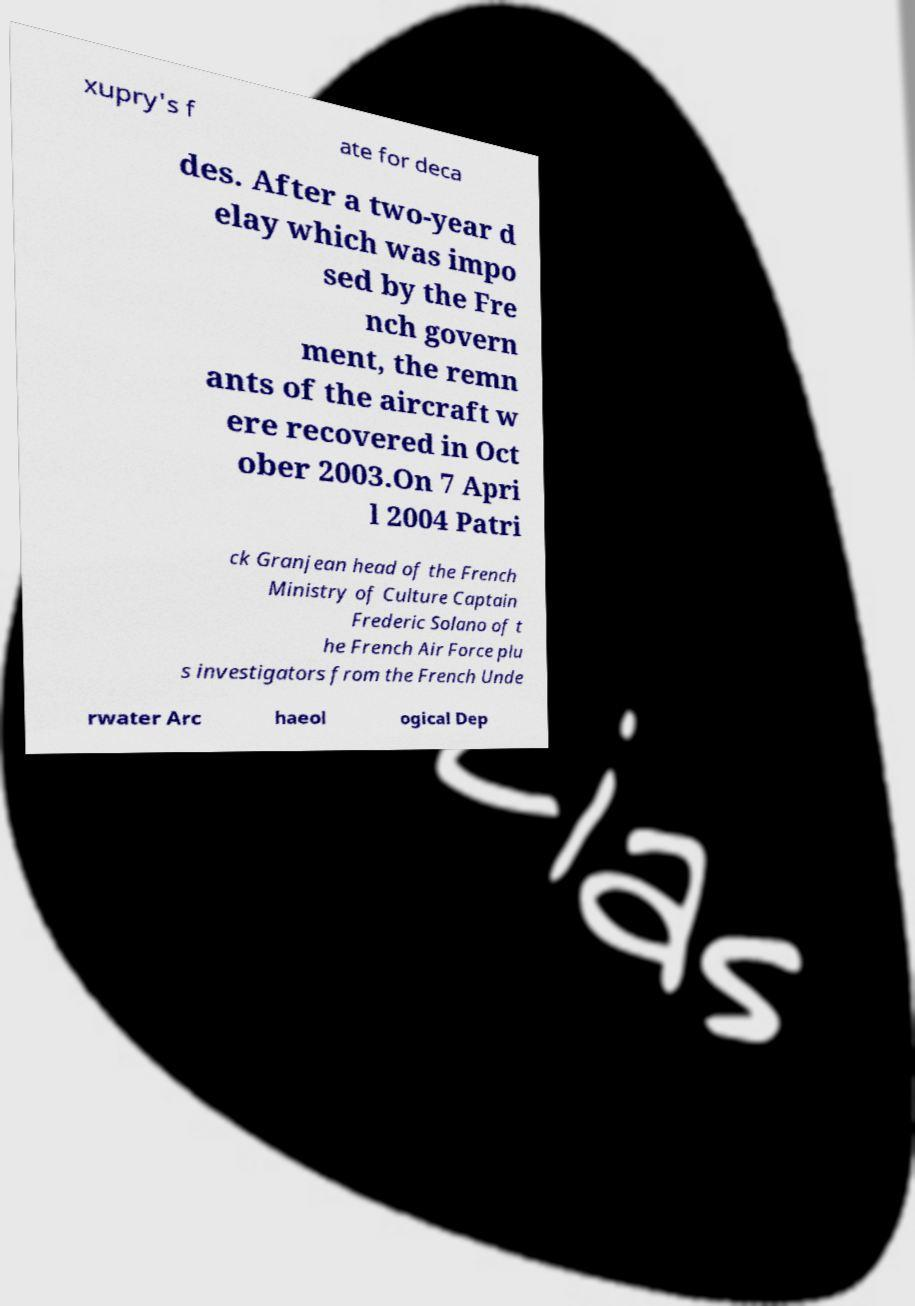For documentation purposes, I need the text within this image transcribed. Could you provide that? xupry's f ate for deca des. After a two-year d elay which was impo sed by the Fre nch govern ment, the remn ants of the aircraft w ere recovered in Oct ober 2003.On 7 Apri l 2004 Patri ck Granjean head of the French Ministry of Culture Captain Frederic Solano of t he French Air Force plu s investigators from the French Unde rwater Arc haeol ogical Dep 